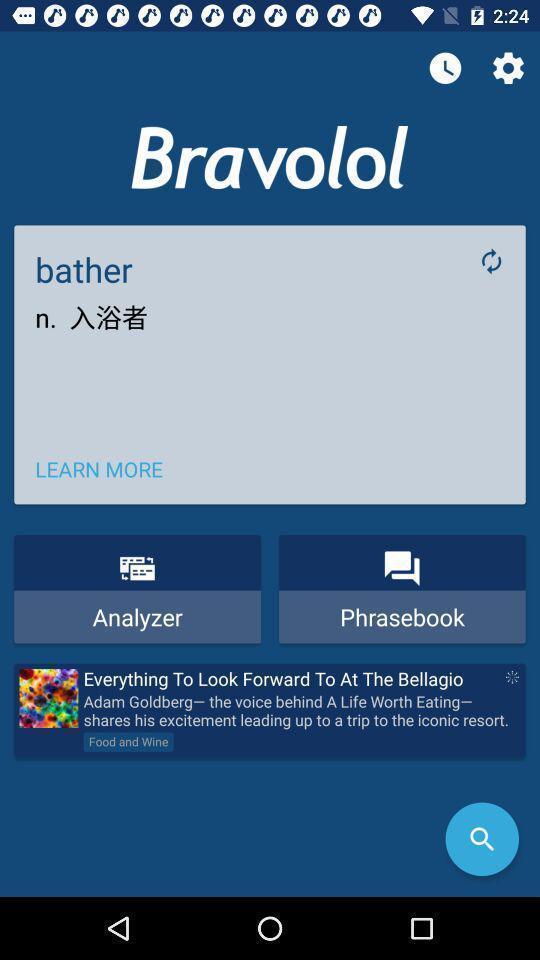Tell me what you see in this picture. Screen shows different options in a learning app. 